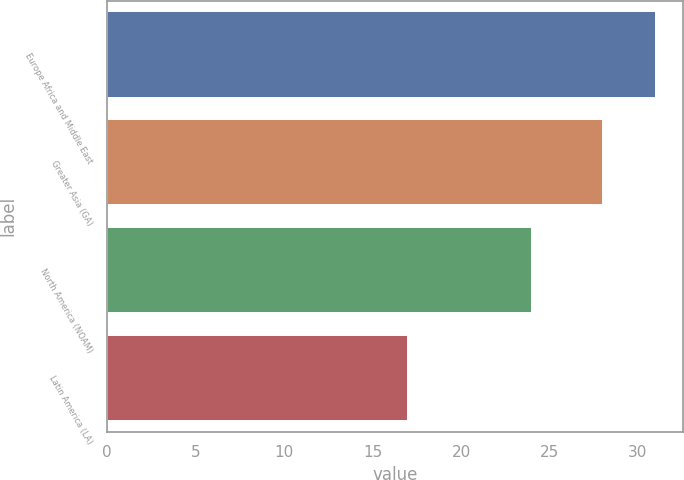<chart> <loc_0><loc_0><loc_500><loc_500><bar_chart><fcel>Europe Africa and Middle East<fcel>Greater Asia (GA)<fcel>North America (NOAM)<fcel>Latin America (LA)<nl><fcel>31<fcel>28<fcel>24<fcel>17<nl></chart> 